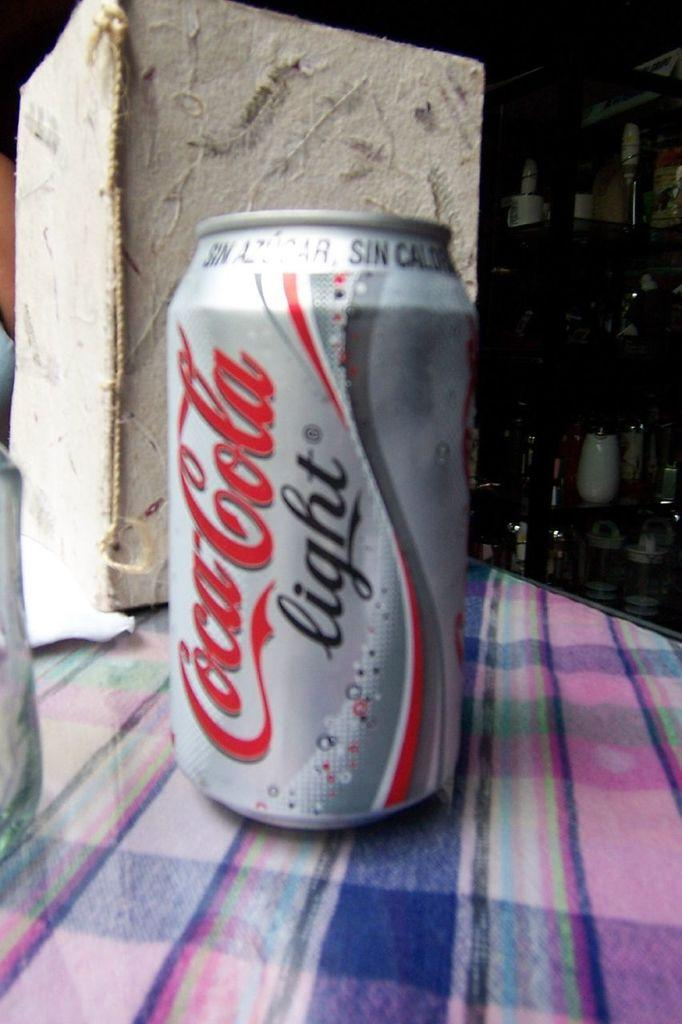<image>
Render a clear and concise summary of the photo. A silver can has the Coca Cola logo on it. 